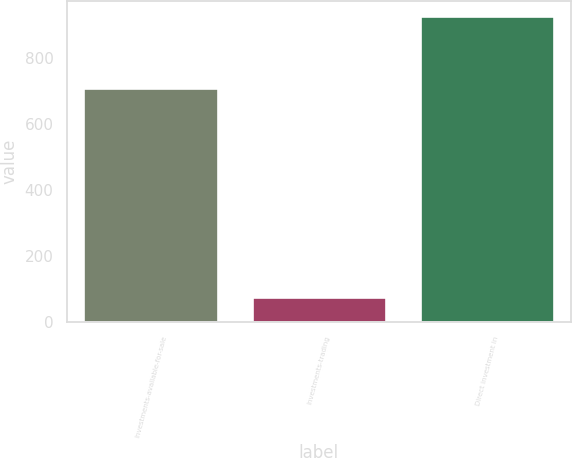<chart> <loc_0><loc_0><loc_500><loc_500><bar_chart><fcel>Investments-available-for-sale<fcel>Investments-trading<fcel>Direct investment in<nl><fcel>709<fcel>75.4<fcel>927.7<nl></chart> 